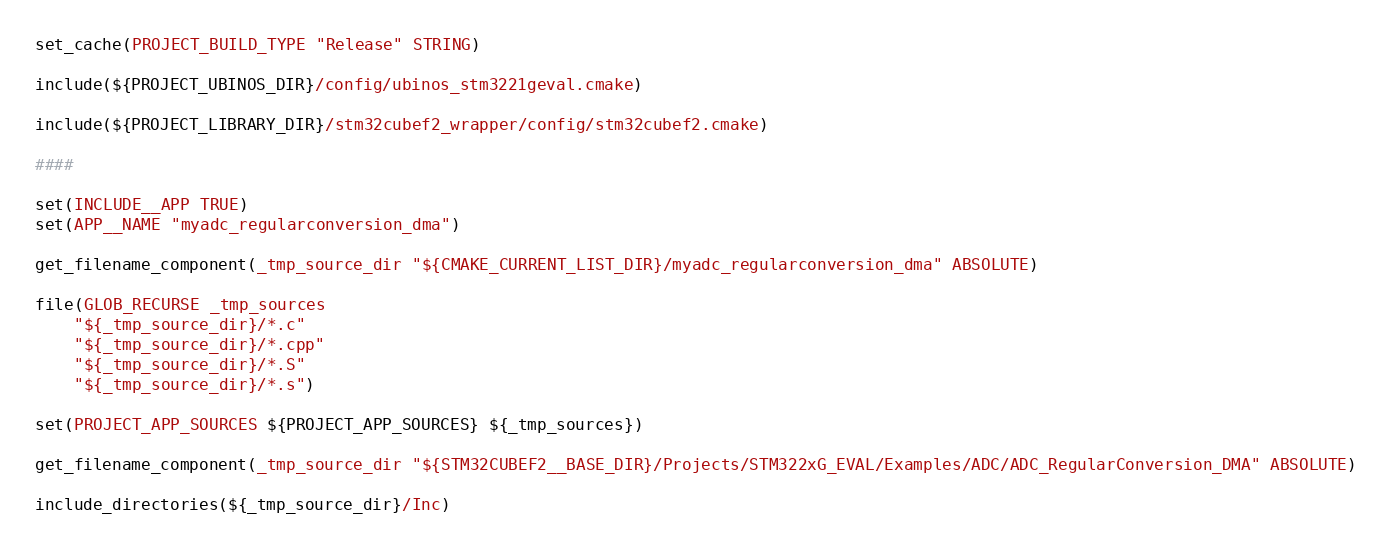Convert code to text. <code><loc_0><loc_0><loc_500><loc_500><_CMake_>set_cache(PROJECT_BUILD_TYPE "Release" STRING)

include(${PROJECT_UBINOS_DIR}/config/ubinos_stm3221geval.cmake)

include(${PROJECT_LIBRARY_DIR}/stm32cubef2_wrapper/config/stm32cubef2.cmake)

####

set(INCLUDE__APP TRUE)
set(APP__NAME "myadc_regularconversion_dma")

get_filename_component(_tmp_source_dir "${CMAKE_CURRENT_LIST_DIR}/myadc_regularconversion_dma" ABSOLUTE)

file(GLOB_RECURSE _tmp_sources
    "${_tmp_source_dir}/*.c"
    "${_tmp_source_dir}/*.cpp"
    "${_tmp_source_dir}/*.S"
    "${_tmp_source_dir}/*.s")

set(PROJECT_APP_SOURCES ${PROJECT_APP_SOURCES} ${_tmp_sources})

get_filename_component(_tmp_source_dir "${STM32CUBEF2__BASE_DIR}/Projects/STM322xG_EVAL/Examples/ADC/ADC_RegularConversion_DMA" ABSOLUTE)

include_directories(${_tmp_source_dir}/Inc)


</code> 